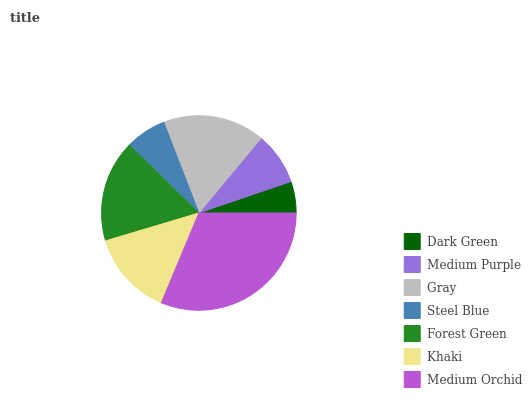Is Dark Green the minimum?
Answer yes or no. Yes. Is Medium Orchid the maximum?
Answer yes or no. Yes. Is Medium Purple the minimum?
Answer yes or no. No. Is Medium Purple the maximum?
Answer yes or no. No. Is Medium Purple greater than Dark Green?
Answer yes or no. Yes. Is Dark Green less than Medium Purple?
Answer yes or no. Yes. Is Dark Green greater than Medium Purple?
Answer yes or no. No. Is Medium Purple less than Dark Green?
Answer yes or no. No. Is Khaki the high median?
Answer yes or no. Yes. Is Khaki the low median?
Answer yes or no. Yes. Is Forest Green the high median?
Answer yes or no. No. Is Dark Green the low median?
Answer yes or no. No. 